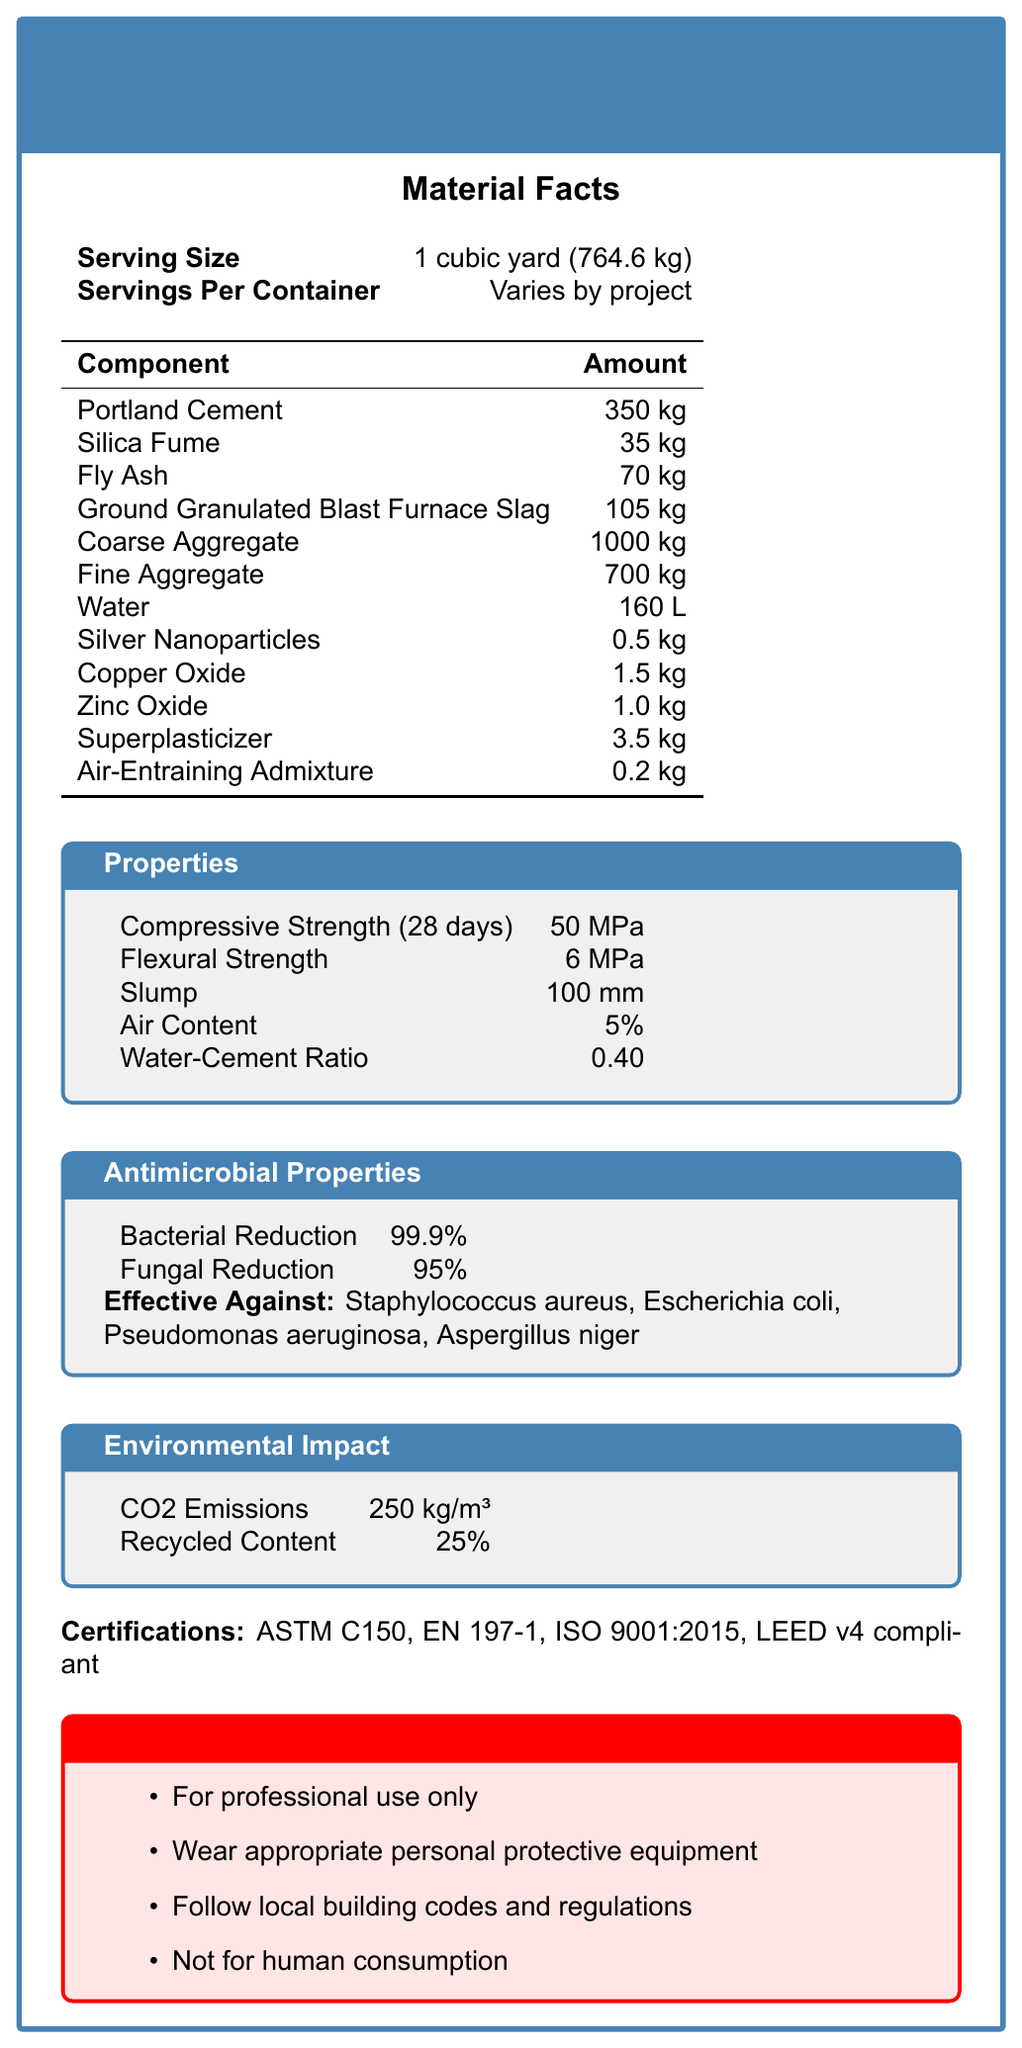What is the serving size for the HospitalGuard Antimicrobial Concrete Mix? The document states that the serving size is 1 cubic yard, which is equivalent to 764.6 kg.
Answer: 1 cubic yard (764.6 kg) What is the compressive strength of the concrete mix after 28 days? The Properties section of the document lists the compressive strength as 50 MPa.
Answer: 50 MPa Name three ingredients in the HospitalGuard Antimicrobial Concrete Mix. The Ingredients section includes Portland Cement, Silica Fume, and Fly Ash, among others.
Answer: Portland Cement, Silica Fume, Fly Ash What is the amount of water required per serving size? In the Composition section, it lists the amount of water as 160 L.
Answer: 160 L Which two antimicrobial agents are included in the concrete mix? The Composition section lists Silver Nanoparticles and Copper Oxide.
Answer: Silver Nanoparticles, Copper Oxide Which of the following bacteria is the HospitalGuard Antimicrobial Concrete Mix effective against? A. Mycobacterium tuberculosis B. Staphylococcus aureus C. Bacillus cereus D. Salmonella enterica The Antimicrobial Properties section specifies that the mix is effective against Staphylococcus aureus.
Answer: B. Staphylococcus aureus Which certification(s) does the HospitalGuard Antimicrobial Concrete Mix have? A. ASTM C150 B. LEED v4 compliant C. ISO 14001 D. Both A and B The Certifications section lists certifications as including ASTM C150 and LEED v4 compliance.
Answer: D. Both A and B Is the HospitalGuard Antimicrobial Concrete Mix suitable for non-professional use? Yes/No The Warnings section clearly states it is for professional use only.
Answer: No Summarize the main purpose of the HospitalGuard Antimicrobial Concrete Mix document. This document appears to be intended for professionals in the construction industry who need detailed information about the product's specifications and safety measures.
Answer: The document provides detailed information about the HospitalGuard Antimicrobial Concrete Mix, including its composition, properties, antimicrobial features, environmental impact, certifications, and usage warnings. What is the air content of the concrete mix? The Properties section lists the air content as 5%.
Answer: 5% What is the carbon dioxide emission per cubic meter of the concrete mix? The Environmental Impact section lists the CO2 emissions as 250 kg/m³.
Answer: 250 kg/m³ What is the daily value percentage of Zinc Oxide in the mix? The Composition section does not provide a daily value percentage for Zinc Oxide, indicating it with "N/A".
Answer: N/A Why is the antimicrobial concrete mix not for human consumption? The document explicitly states this in the Warnings section, but does not provide a detailed reasoning.
Answer: Not enough information What is the flexural strength of the HospitalGuard Antimicrobial Concrete Mix? The Properties section lists the flexural strength as 6 MPa.
Answer: 6 MPa Does the concrete mix have any ingredients that enhance its plasticity? The superplasticizer is listed in the Composition section, which enhances the plasticity of the concrete mix.
Answer: Yes 